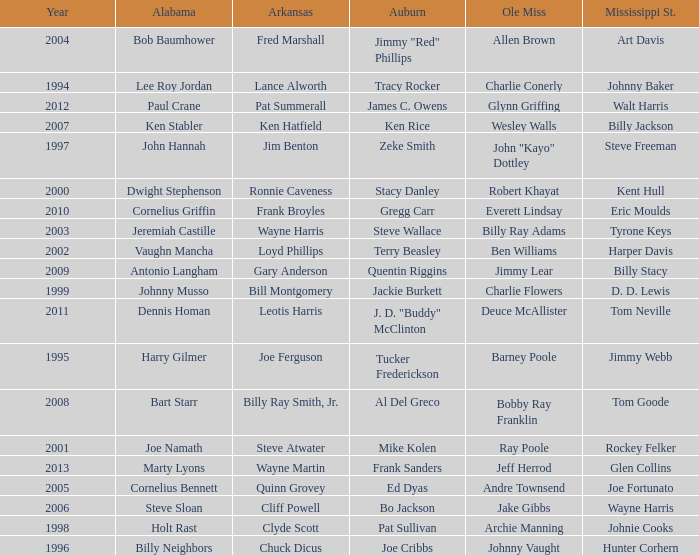Who was the Ole Miss player associated with Chuck Dicus? Johnny Vaught. 